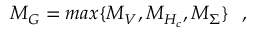Convert formula to latex. <formula><loc_0><loc_0><loc_500><loc_500>M _ { G } = \max \{ M _ { V } , M _ { H _ { c } } , M _ { \Sigma } \} \, ,</formula> 